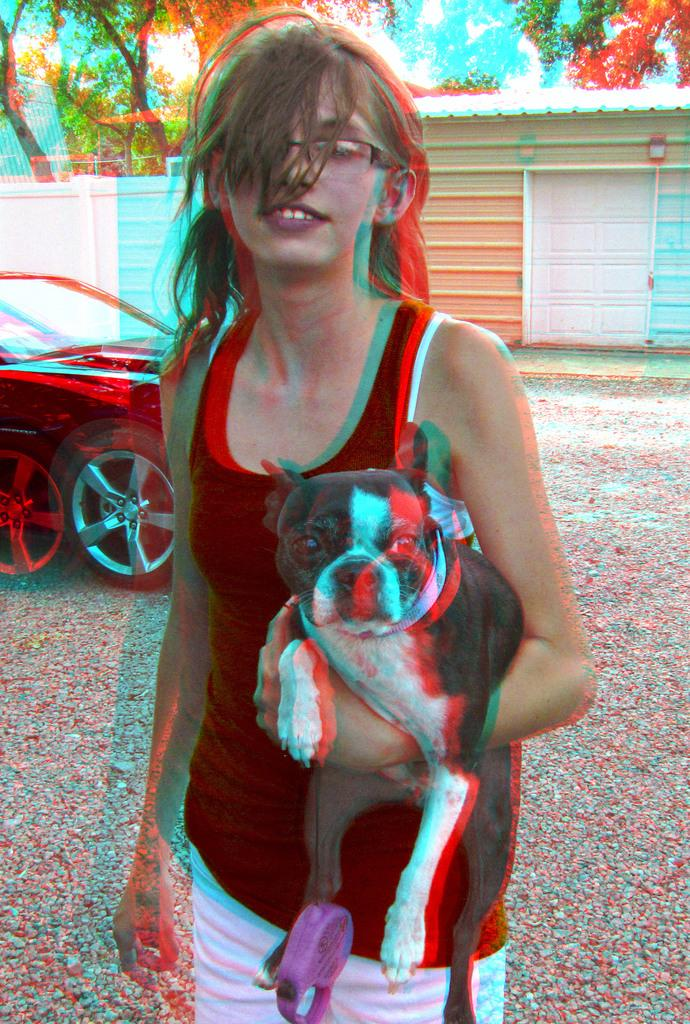Who is in the image? There is a woman in the image. What is the woman wearing? The woman is wearing a black t-shirt. What is the woman holding in the image? The woman is holding a dog. What can be seen behind the woman? There is a car and a shed behind the woman. What type of weather can be seen in the image? There is no indication of the weather in the image. The image only shows a woman holding a dog, a car, and a shed in the background. 